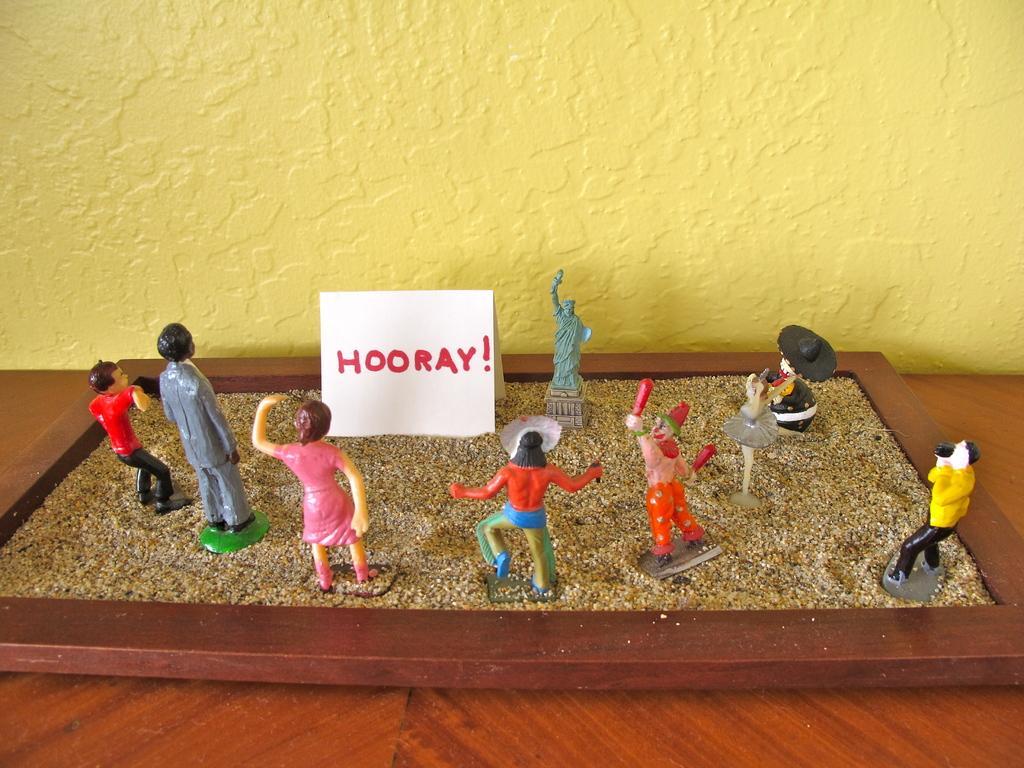Could you give a brief overview of what you see in this image? In the image there are toys in a tray of sand on a table in front of yellow wall. 